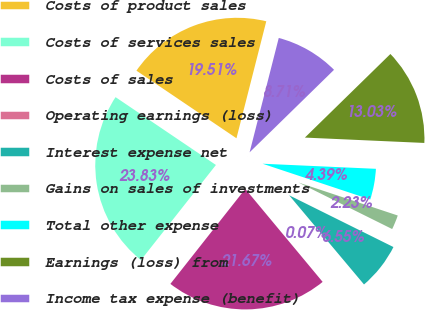Convert chart. <chart><loc_0><loc_0><loc_500><loc_500><pie_chart><fcel>Costs of product sales<fcel>Costs of services sales<fcel>Costs of sales<fcel>Operating earnings (loss)<fcel>Interest expense net<fcel>Gains on sales of investments<fcel>Total other expense<fcel>Earnings (loss) from<fcel>Income tax expense (benefit)<nl><fcel>19.51%<fcel>23.83%<fcel>21.67%<fcel>0.07%<fcel>6.55%<fcel>2.23%<fcel>4.39%<fcel>13.03%<fcel>8.71%<nl></chart> 